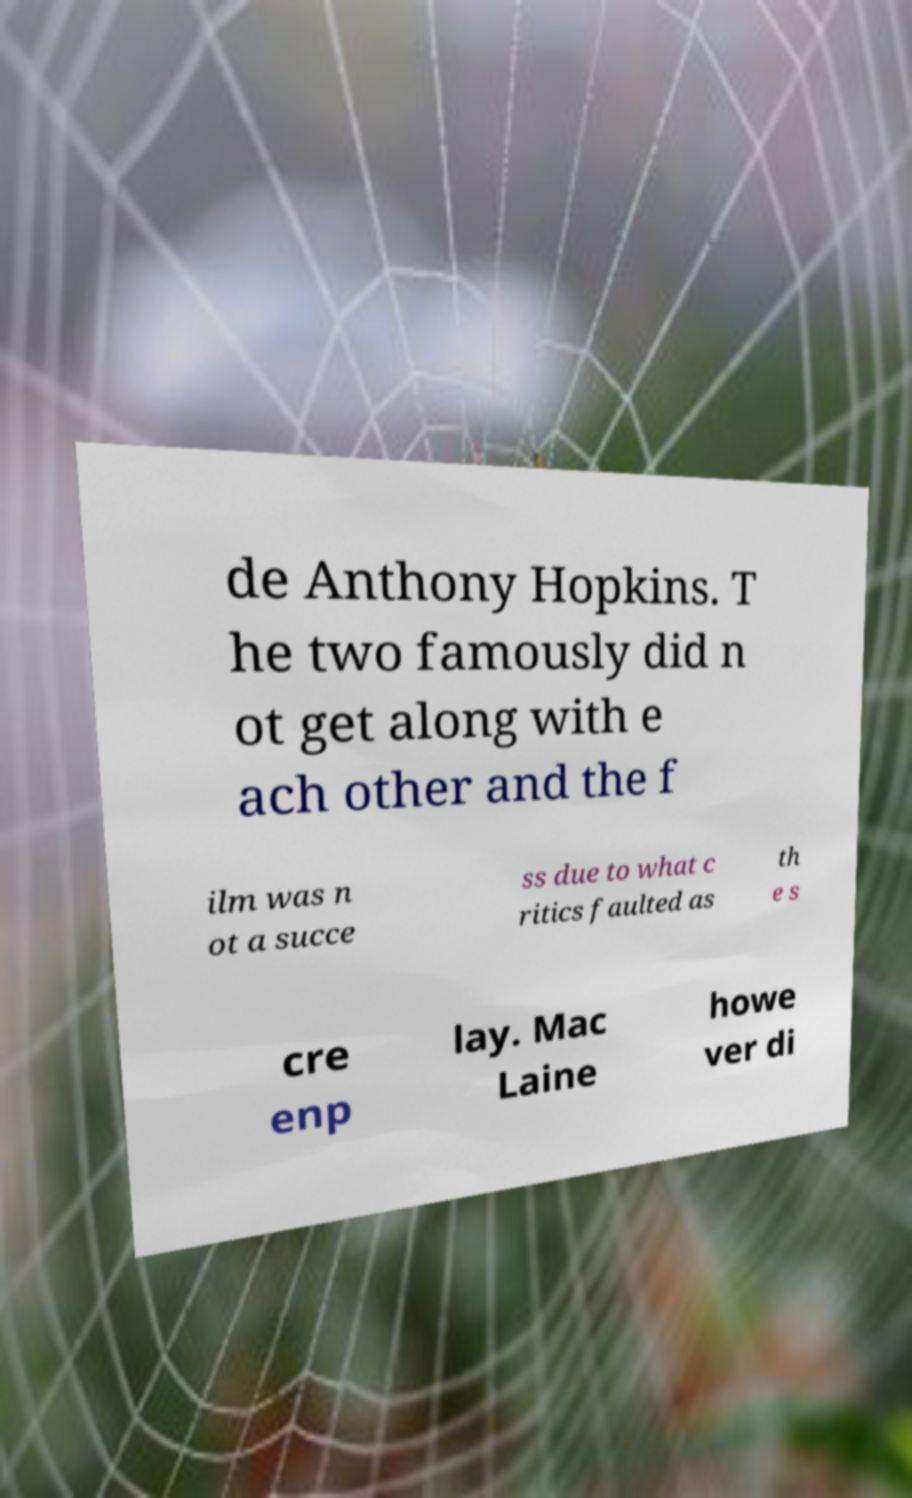There's text embedded in this image that I need extracted. Can you transcribe it verbatim? de Anthony Hopkins. T he two famously did n ot get along with e ach other and the f ilm was n ot a succe ss due to what c ritics faulted as th e s cre enp lay. Mac Laine howe ver di 